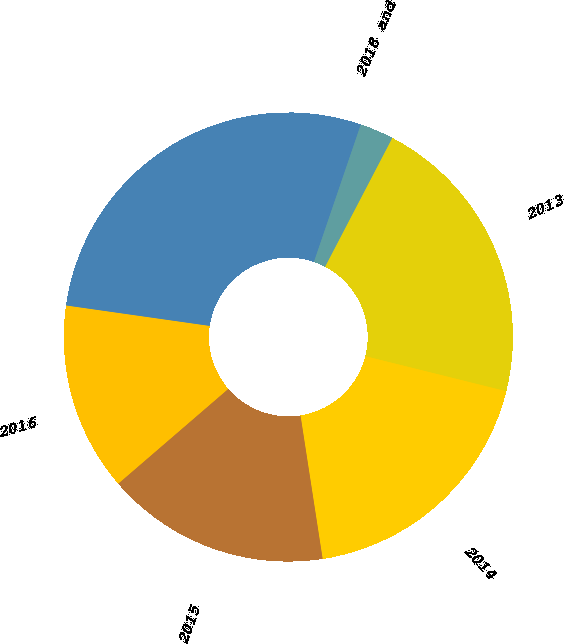Convert chart to OTSL. <chart><loc_0><loc_0><loc_500><loc_500><pie_chart><fcel>2013<fcel>2014<fcel>2015<fcel>2016<fcel>2017<fcel>2018 and thereafter<nl><fcel>21.23%<fcel>18.68%<fcel>16.12%<fcel>13.57%<fcel>27.98%<fcel>2.42%<nl></chart> 